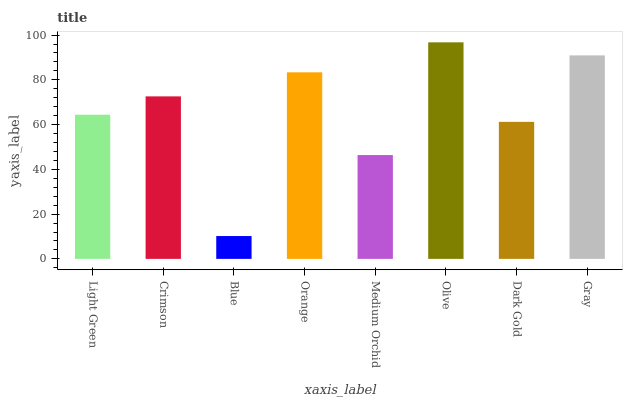Is Blue the minimum?
Answer yes or no. Yes. Is Olive the maximum?
Answer yes or no. Yes. Is Crimson the minimum?
Answer yes or no. No. Is Crimson the maximum?
Answer yes or no. No. Is Crimson greater than Light Green?
Answer yes or no. Yes. Is Light Green less than Crimson?
Answer yes or no. Yes. Is Light Green greater than Crimson?
Answer yes or no. No. Is Crimson less than Light Green?
Answer yes or no. No. Is Crimson the high median?
Answer yes or no. Yes. Is Light Green the low median?
Answer yes or no. Yes. Is Gray the high median?
Answer yes or no. No. Is Dark Gold the low median?
Answer yes or no. No. 